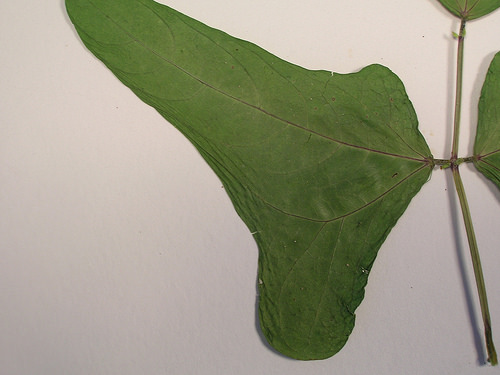<image>
Can you confirm if the wall is behind the leaves? Yes. From this viewpoint, the wall is positioned behind the leaves, with the leaves partially or fully occluding the wall. 